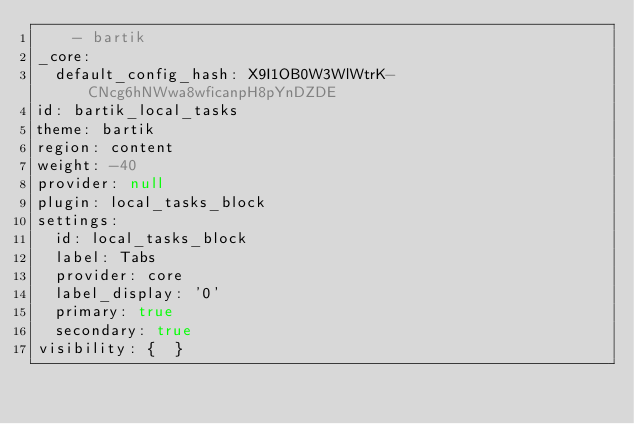<code> <loc_0><loc_0><loc_500><loc_500><_YAML_>    - bartik
_core:
  default_config_hash: X9I1OB0W3WlWtrK-CNcg6hNWwa8wficanpH8pYnDZDE
id: bartik_local_tasks
theme: bartik
region: content
weight: -40
provider: null
plugin: local_tasks_block
settings:
  id: local_tasks_block
  label: Tabs
  provider: core
  label_display: '0'
  primary: true
  secondary: true
visibility: {  }
</code> 